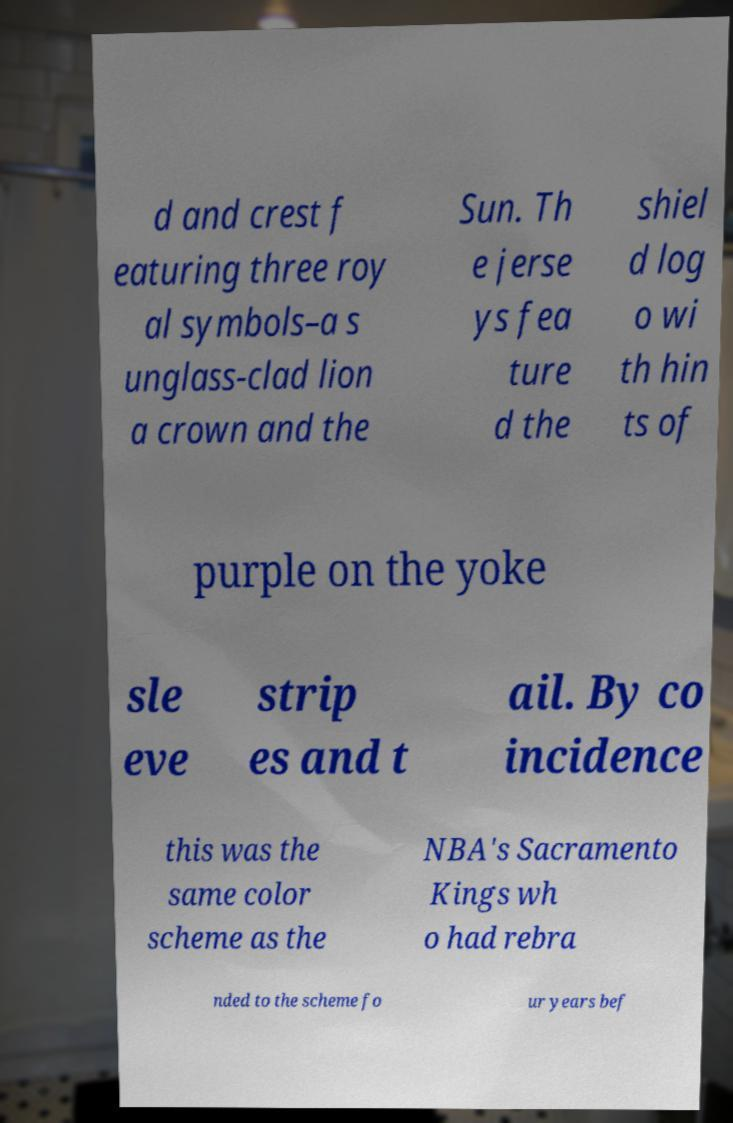Can you accurately transcribe the text from the provided image for me? d and crest f eaturing three roy al symbols–a s unglass-clad lion a crown and the Sun. Th e jerse ys fea ture d the shiel d log o wi th hin ts of purple on the yoke sle eve strip es and t ail. By co incidence this was the same color scheme as the NBA's Sacramento Kings wh o had rebra nded to the scheme fo ur years bef 